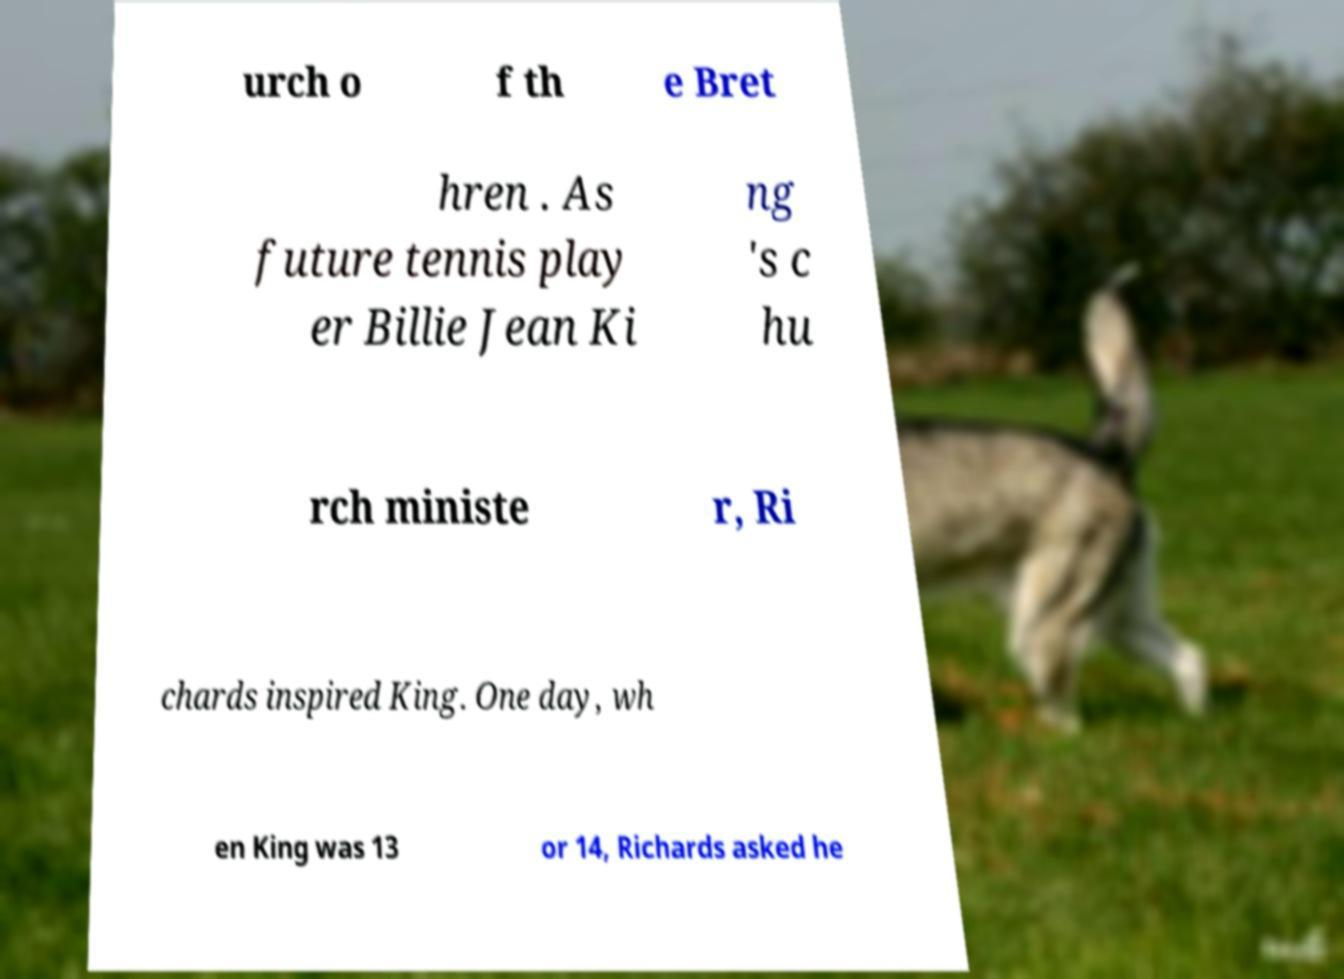I need the written content from this picture converted into text. Can you do that? urch o f th e Bret hren . As future tennis play er Billie Jean Ki ng 's c hu rch ministe r, Ri chards inspired King. One day, wh en King was 13 or 14, Richards asked he 